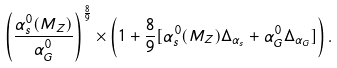Convert formula to latex. <formula><loc_0><loc_0><loc_500><loc_500>\left ( \frac { \alpha _ { s } ^ { 0 } ( M _ { Z } ) } { \alpha _ { G } ^ { 0 } } \right ) ^ { \frac { 8 } { 9 } } \times \left ( 1 + \frac { 8 } { 9 } [ \alpha _ { s } ^ { 0 } ( M _ { Z } ) \Delta _ { \alpha _ { s } } + \alpha _ { G } ^ { 0 } \Delta _ { \alpha _ { G } } ] \right ) .</formula> 